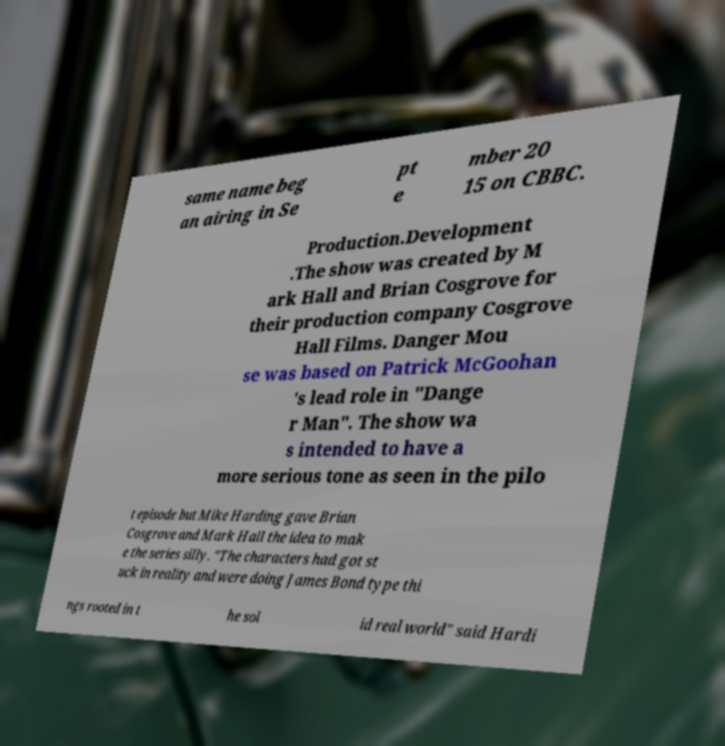Please read and relay the text visible in this image. What does it say? same name beg an airing in Se pt e mber 20 15 on CBBC. Production.Development .The show was created by M ark Hall and Brian Cosgrove for their production company Cosgrove Hall Films. Danger Mou se was based on Patrick McGoohan 's lead role in "Dange r Man". The show wa s intended to have a more serious tone as seen in the pilo t episode but Mike Harding gave Brian Cosgrove and Mark Hall the idea to mak e the series silly. "The characters had got st uck in reality and were doing James Bond type thi ngs rooted in t he sol id real world" said Hardi 